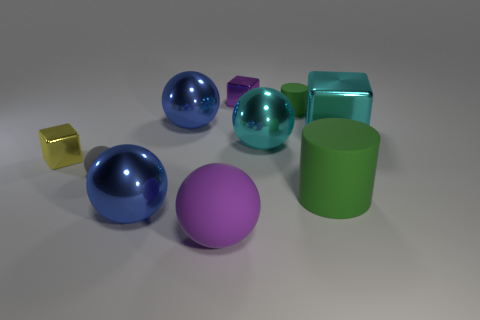What is the material of the large object that is the same color as the big shiny cube?
Offer a very short reply. Metal. Are there more tiny balls that are in front of the large cylinder than large objects?
Offer a terse response. No. Is the tiny green rubber object the same shape as the large purple thing?
Offer a terse response. No. What number of large green cylinders have the same material as the gray ball?
Offer a terse response. 1. The cyan object that is the same shape as the small yellow object is what size?
Provide a short and direct response. Large. Do the purple sphere and the cyan metallic sphere have the same size?
Your response must be concise. Yes. What shape is the rubber object behind the rubber object that is on the left side of the big metallic sphere that is in front of the gray object?
Make the answer very short. Cylinder. What color is the big object that is the same shape as the tiny yellow shiny thing?
Make the answer very short. Cyan. There is a metal block that is on the right side of the small yellow metal block and in front of the purple metallic cube; what size is it?
Your answer should be compact. Large. There is a purple object that is in front of the large blue thing that is behind the gray matte ball; how many metal balls are left of it?
Offer a terse response. 2. 